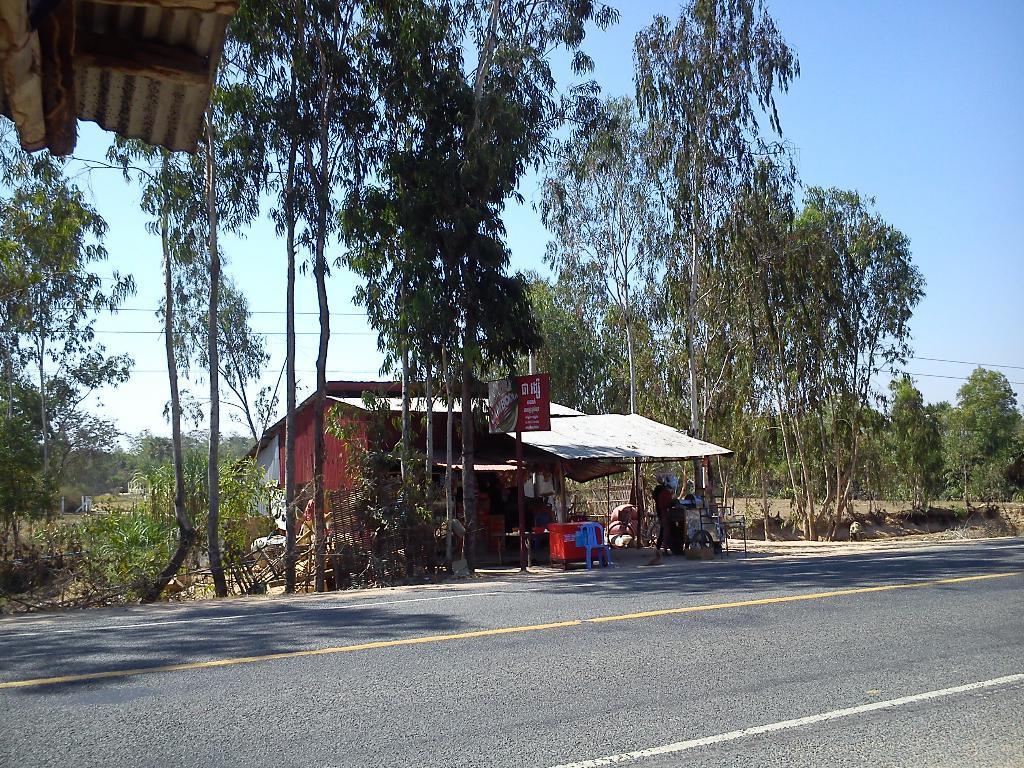Describe this image in one or two sentences. In this image we can see a road, shop, a person, chair, table, wooden pieces and trees. At the top of the image, we can see a shed and the sky. 